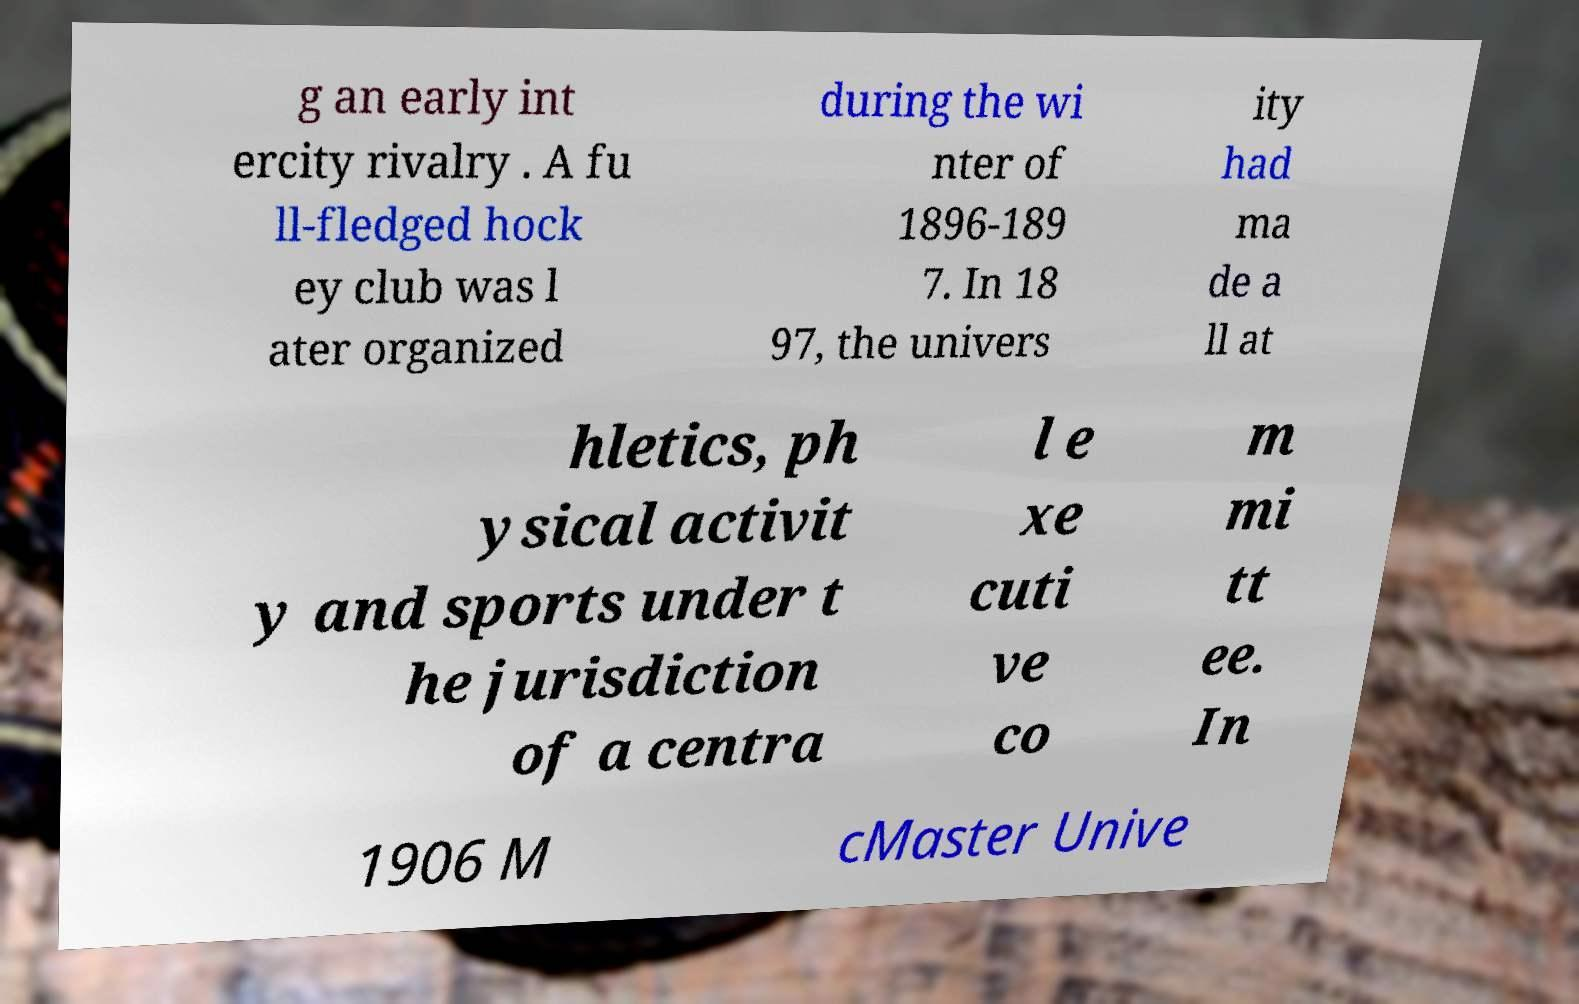There's text embedded in this image that I need extracted. Can you transcribe it verbatim? g an early int ercity rivalry . A fu ll-fledged hock ey club was l ater organized during the wi nter of 1896-189 7. In 18 97, the univers ity had ma de a ll at hletics, ph ysical activit y and sports under t he jurisdiction of a centra l e xe cuti ve co m mi tt ee. In 1906 M cMaster Unive 